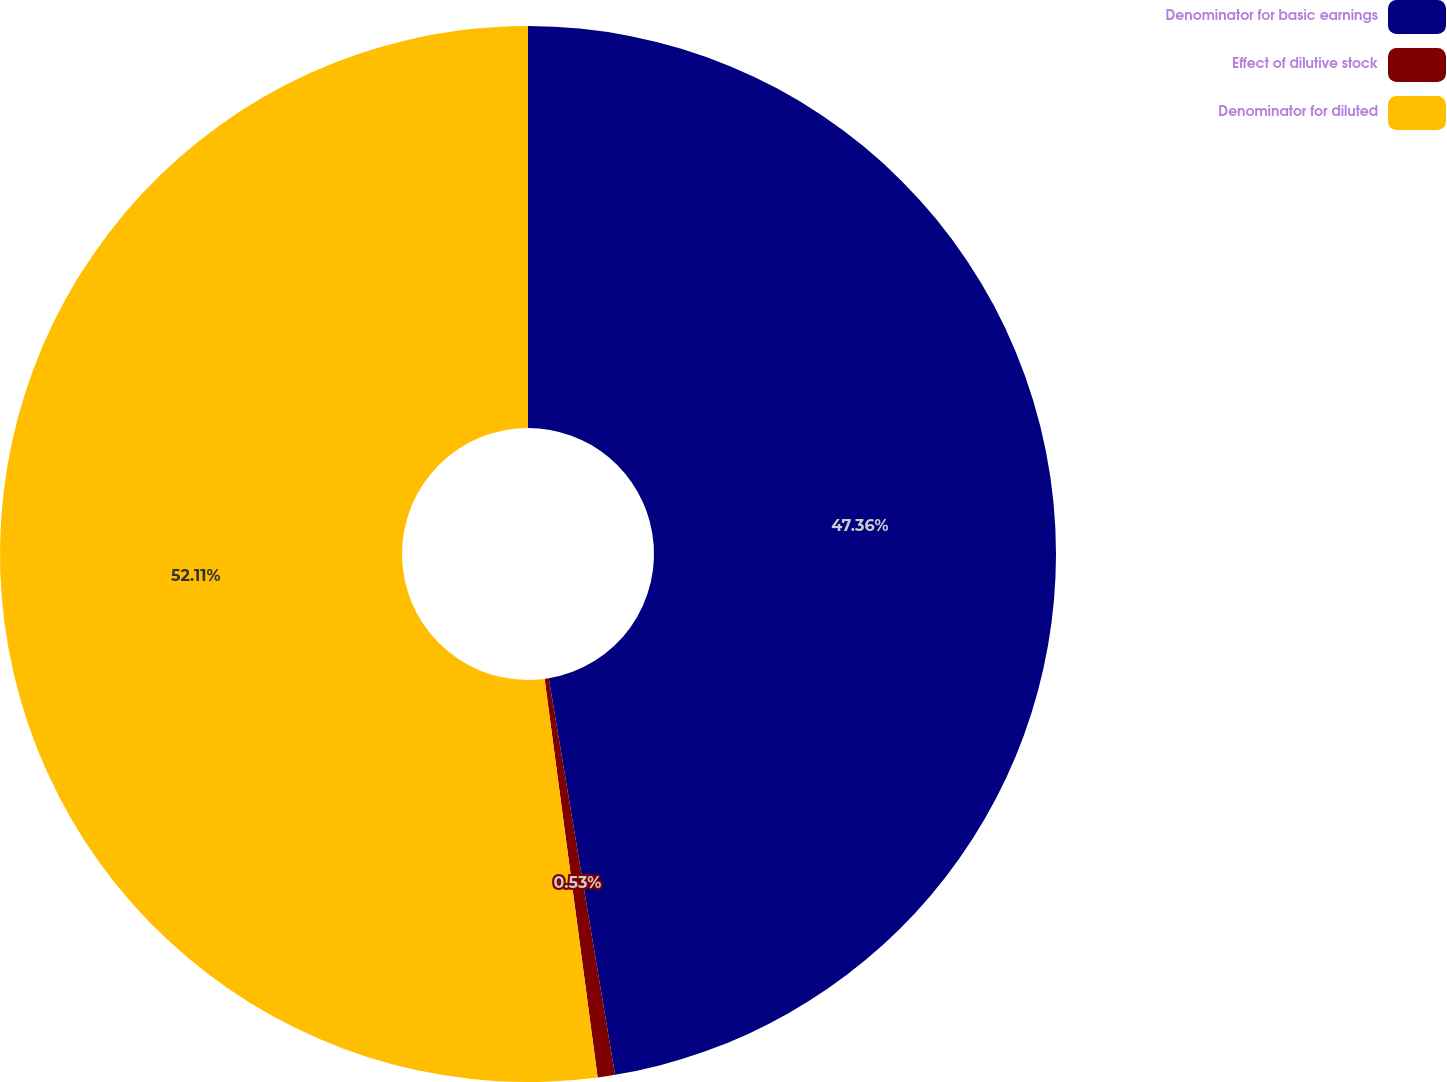Convert chart to OTSL. <chart><loc_0><loc_0><loc_500><loc_500><pie_chart><fcel>Denominator for basic earnings<fcel>Effect of dilutive stock<fcel>Denominator for diluted<nl><fcel>47.36%<fcel>0.53%<fcel>52.1%<nl></chart> 